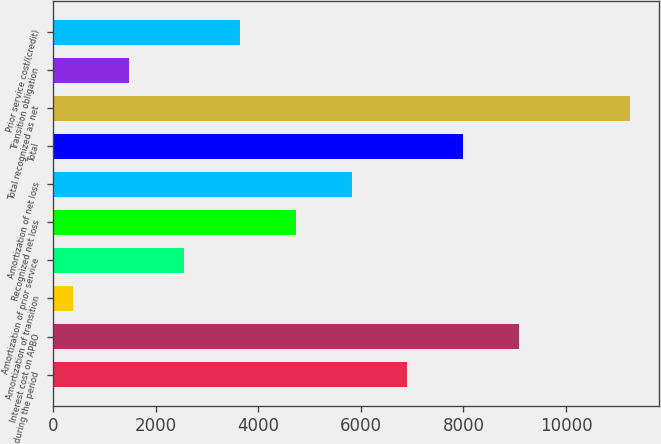Convert chart. <chart><loc_0><loc_0><loc_500><loc_500><bar_chart><fcel>during the period<fcel>Interest cost on APBO<fcel>Amortization of transition<fcel>Amortization of prior service<fcel>Recognized net loss<fcel>Amortization of net loss<fcel>Total<fcel>Total recognized as net<fcel>Transition obligation<fcel>Prior service cost/(credit)<nl><fcel>6906.4<fcel>9081.2<fcel>382<fcel>2556.8<fcel>4731.6<fcel>5819<fcel>7993.8<fcel>11256<fcel>1469.4<fcel>3644.2<nl></chart> 